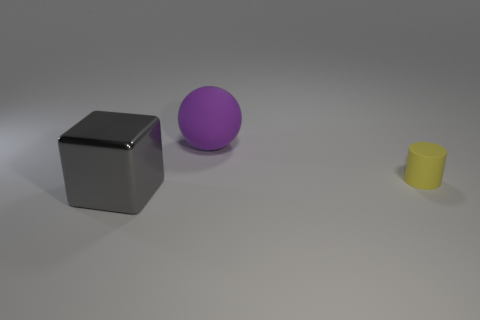There is a cylinder that is made of the same material as the purple ball; what size is it?
Keep it short and to the point. Small. Is the number of big cubes less than the number of rubber objects?
Offer a terse response. Yes. What number of big objects are either purple metal balls or cylinders?
Your answer should be very brief. 0. What number of things are both behind the rubber cylinder and in front of the yellow rubber object?
Ensure brevity in your answer.  0. Is the number of large yellow matte spheres greater than the number of gray cubes?
Your answer should be compact. No. How many other objects are the same shape as the yellow thing?
Your response must be concise. 0. The thing that is right of the big gray thing and to the left of the yellow thing is made of what material?
Offer a very short reply. Rubber. The yellow cylinder has what size?
Ensure brevity in your answer.  Small. There is a large object left of the big object that is behind the metallic cube; how many spheres are in front of it?
Provide a short and direct response. 0. The matte thing that is in front of the large thing behind the tiny cylinder is what shape?
Offer a terse response. Cylinder. 